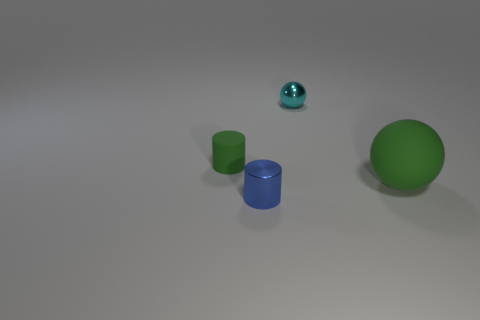What material is the tiny thing that is both behind the green rubber ball and in front of the tiny metallic sphere?
Offer a very short reply. Rubber. Does the blue cylinder have the same size as the green object that is right of the tiny cyan metal sphere?
Provide a succinct answer. No. Is there a green cylinder?
Your answer should be compact. Yes. There is another small object that is the same shape as the blue metal object; what material is it?
Offer a very short reply. Rubber. What is the size of the green thing that is left of the large green matte ball to the right of the object that is on the left side of the blue metal thing?
Your answer should be very brief. Small. There is a tiny green rubber cylinder; are there any tiny green things to the right of it?
Give a very brief answer. No. What size is the cyan object that is made of the same material as the blue object?
Your answer should be very brief. Small. How many small red matte things have the same shape as the small green object?
Make the answer very short. 0. Do the tiny cyan object and the green thing behind the rubber sphere have the same material?
Your answer should be compact. No. Are there more large matte spheres in front of the green matte sphere than small green cylinders?
Your answer should be very brief. No. 